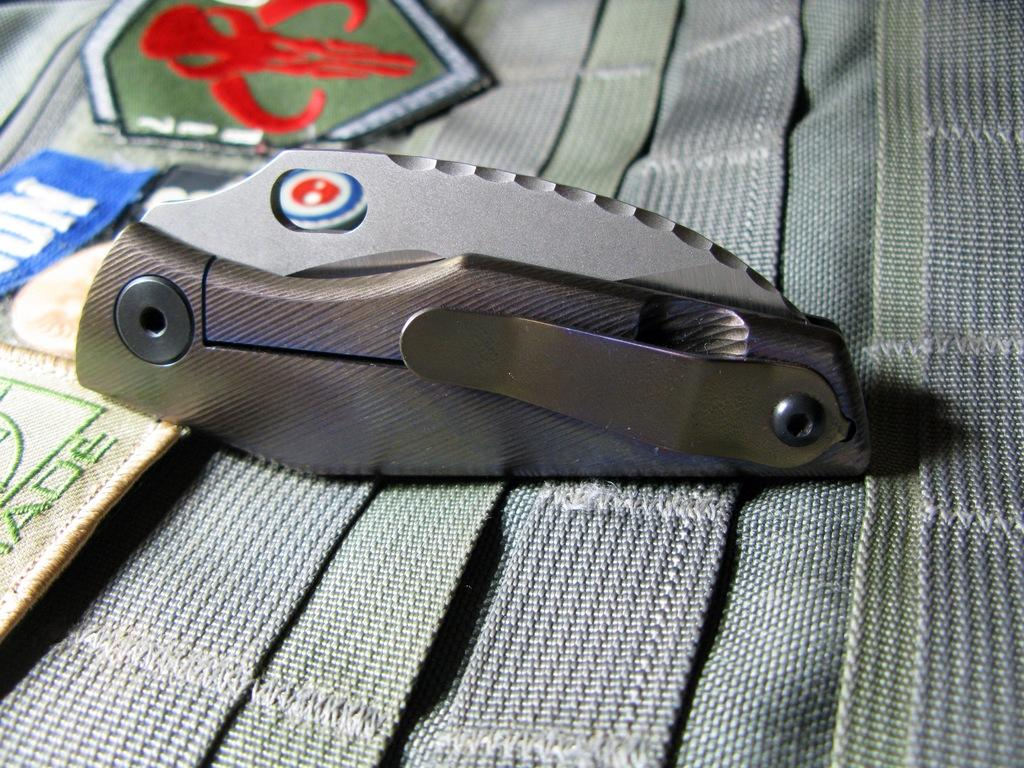What type of items are featured in the image? There are cloth badges in the image. Can you describe the object on the mat in the image? Unfortunately, the facts provided do not give any details about the object on the mat. However, we can confirm that there is an object on the mat. How do the giants interact with the cloth badges in the image? There are no giants present in the image, so they cannot interact with the cloth badges. 